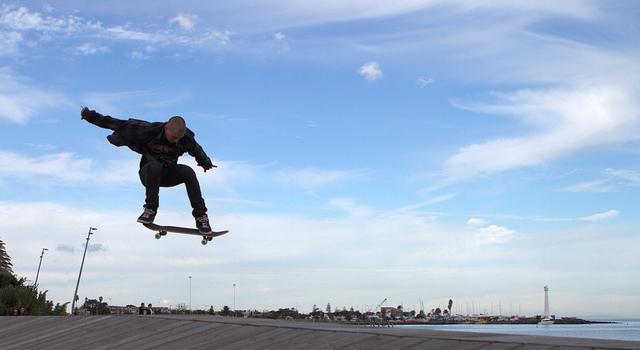How many people are in the picture?
Concise answer only. 1. What is the man doing?
Write a very short answer. Skateboarding. Is it raining?
Concise answer only. No. How many people are in this picture?
Keep it brief. 1. Does the man have hair?
Give a very brief answer. No. 